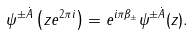Convert formula to latex. <formula><loc_0><loc_0><loc_500><loc_500>\psi ^ { \pm \dot { A } } \left ( z e ^ { 2 \pi i } \right ) = e ^ { i \pi \beta _ { \pm } } \psi ^ { \pm \dot { A } } ( z ) .</formula> 